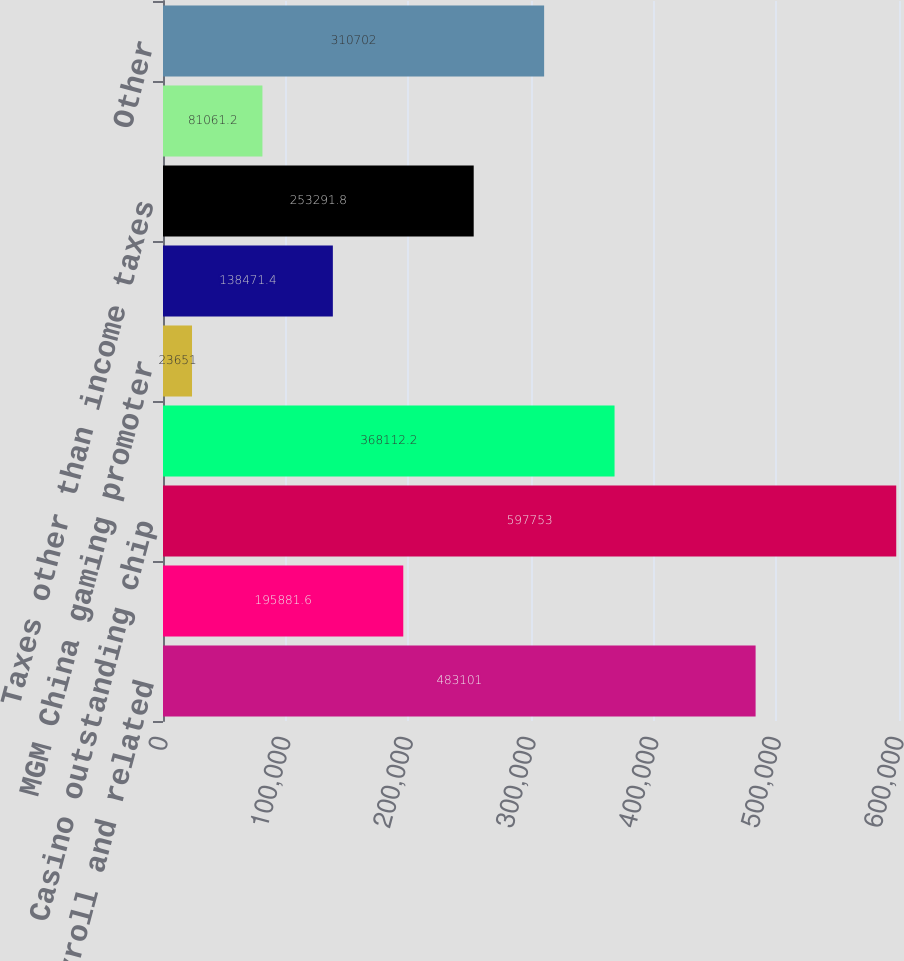<chart> <loc_0><loc_0><loc_500><loc_500><bar_chart><fcel>Payroll and related<fcel>Advance deposits and ticket<fcel>Casino outstanding chip<fcel>Casino front money deposits<fcel>MGM China gaming promoter<fcel>Other gaming related accruals<fcel>Taxes other than income taxes<fcel>MGP Dividend<fcel>Other<nl><fcel>483101<fcel>195882<fcel>597753<fcel>368112<fcel>23651<fcel>138471<fcel>253292<fcel>81061.2<fcel>310702<nl></chart> 